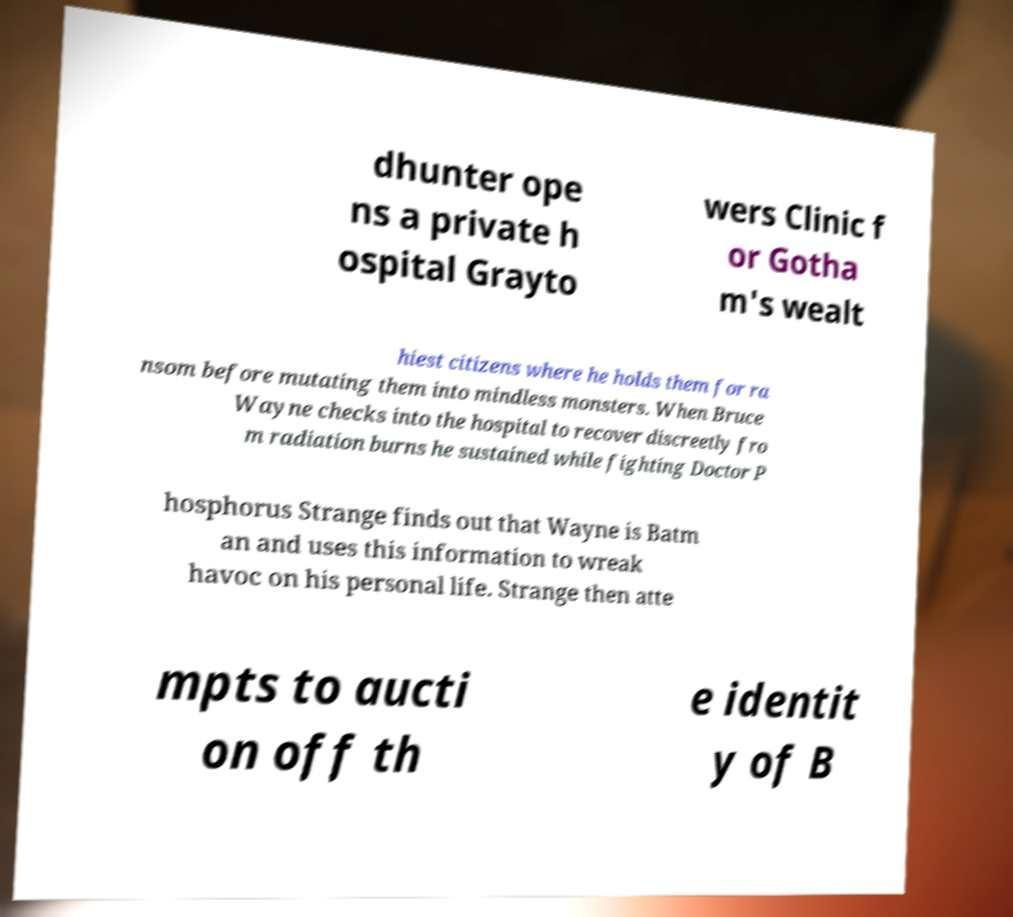What messages or text are displayed in this image? I need them in a readable, typed format. dhunter ope ns a private h ospital Grayto wers Clinic f or Gotha m's wealt hiest citizens where he holds them for ra nsom before mutating them into mindless monsters. When Bruce Wayne checks into the hospital to recover discreetly fro m radiation burns he sustained while fighting Doctor P hosphorus Strange finds out that Wayne is Batm an and uses this information to wreak havoc on his personal life. Strange then atte mpts to aucti on off th e identit y of B 